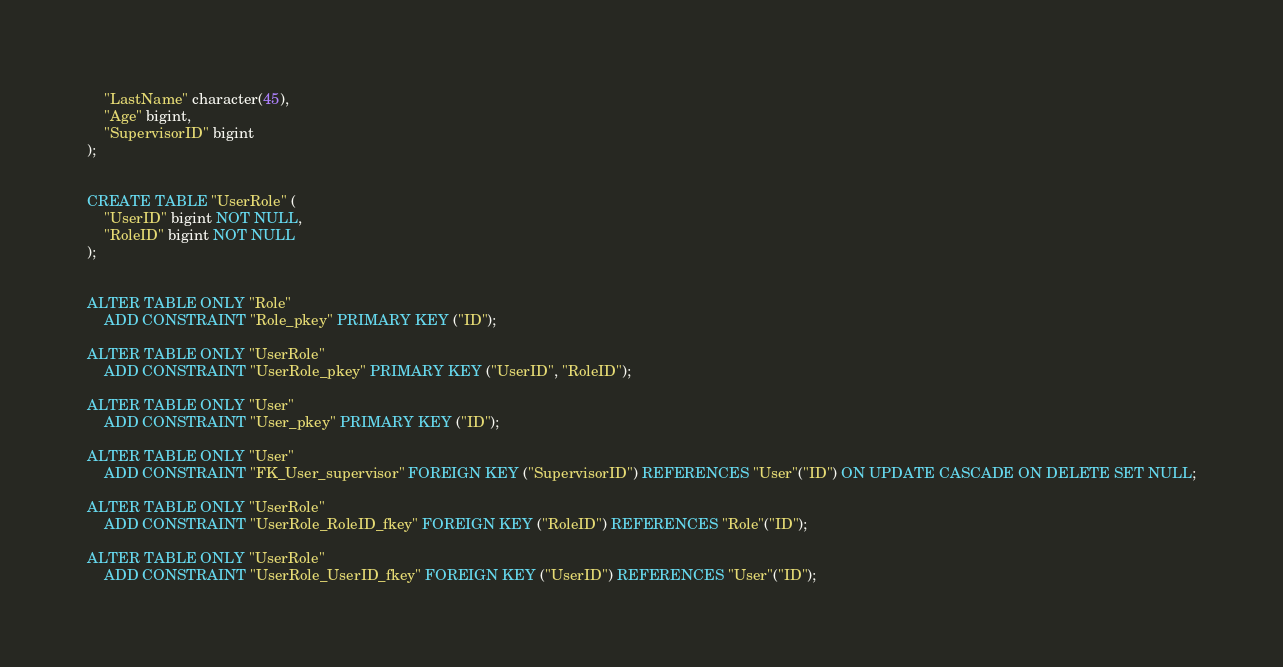Convert code to text. <code><loc_0><loc_0><loc_500><loc_500><_SQL_>    "LastName" character(45),
    "Age" bigint,
    "SupervisorID" bigint
);


CREATE TABLE "UserRole" (
    "UserID" bigint NOT NULL,
    "RoleID" bigint NOT NULL
);


ALTER TABLE ONLY "Role"
    ADD CONSTRAINT "Role_pkey" PRIMARY KEY ("ID");

ALTER TABLE ONLY "UserRole"
    ADD CONSTRAINT "UserRole_pkey" PRIMARY KEY ("UserID", "RoleID");

ALTER TABLE ONLY "User"
    ADD CONSTRAINT "User_pkey" PRIMARY KEY ("ID");

ALTER TABLE ONLY "User"
    ADD CONSTRAINT "FK_User_supervisor" FOREIGN KEY ("SupervisorID") REFERENCES "User"("ID") ON UPDATE CASCADE ON DELETE SET NULL;

ALTER TABLE ONLY "UserRole"
    ADD CONSTRAINT "UserRole_RoleID_fkey" FOREIGN KEY ("RoleID") REFERENCES "Role"("ID");

ALTER TABLE ONLY "UserRole"
    ADD CONSTRAINT "UserRole_UserID_fkey" FOREIGN KEY ("UserID") REFERENCES "User"("ID");

</code> 